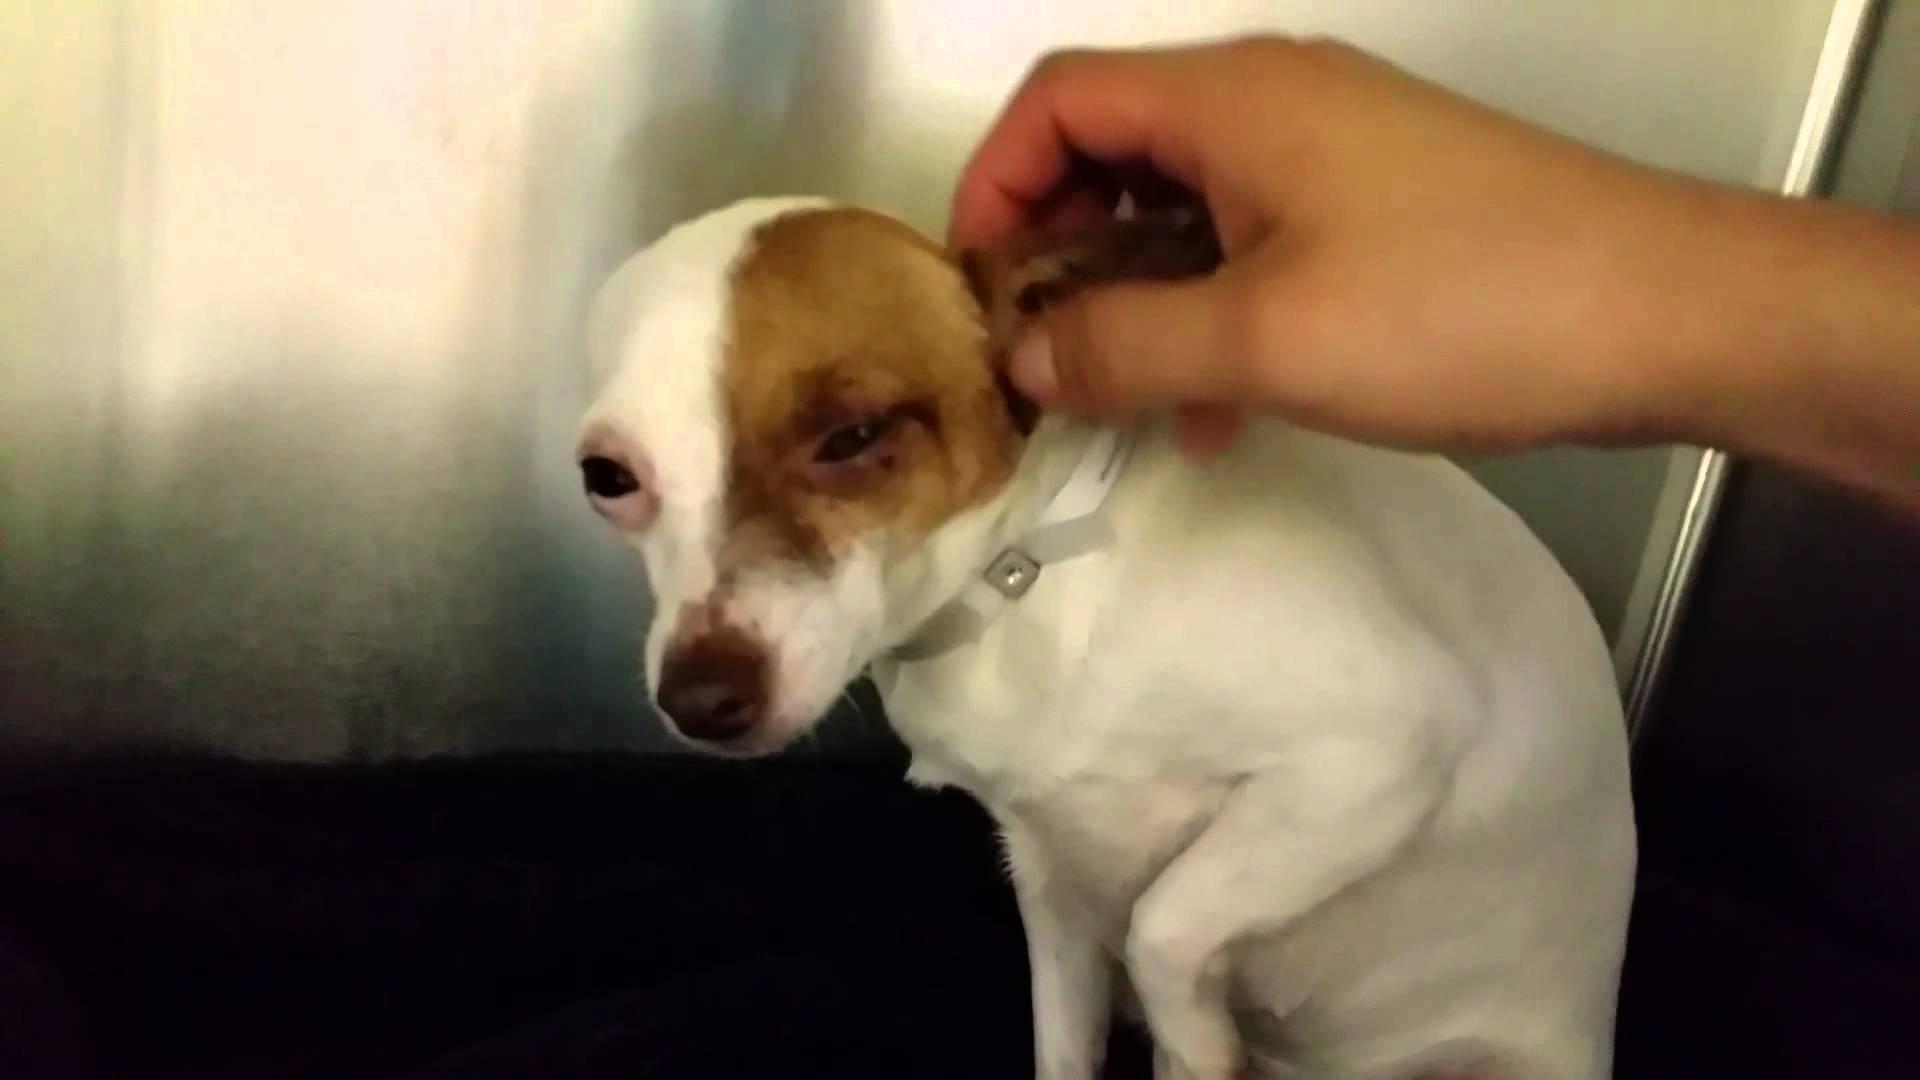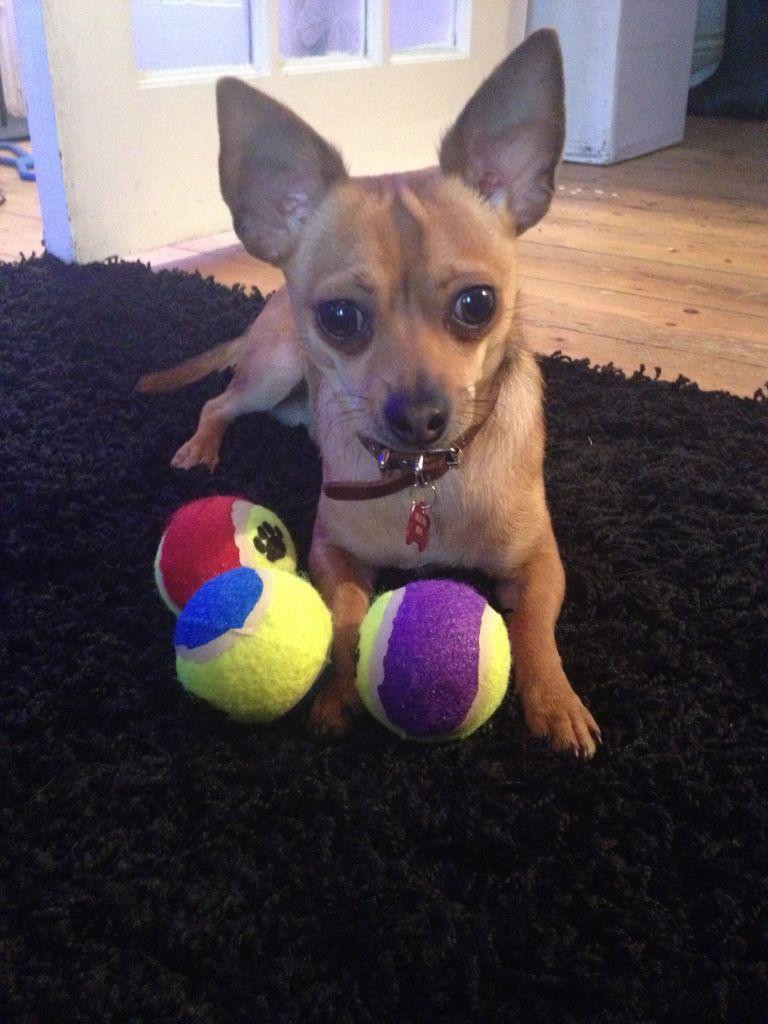The first image is the image on the left, the second image is the image on the right. Evaluate the accuracy of this statement regarding the images: "A chihuahua is sitting on a rug.". Is it true? Answer yes or no. Yes. The first image is the image on the left, the second image is the image on the right. Analyze the images presented: Is the assertion "The dog in the image on the left has a white collar." valid? Answer yes or no. Yes. 